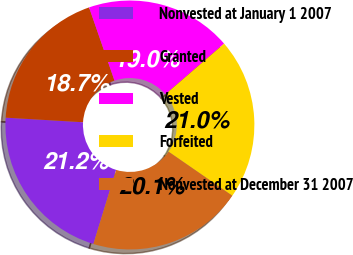Convert chart. <chart><loc_0><loc_0><loc_500><loc_500><pie_chart><fcel>Nonvested at January 1 2007<fcel>Granted<fcel>Vested<fcel>Forfeited<fcel>Nonvested at December 31 2007<nl><fcel>21.2%<fcel>18.74%<fcel>18.98%<fcel>20.96%<fcel>20.11%<nl></chart> 